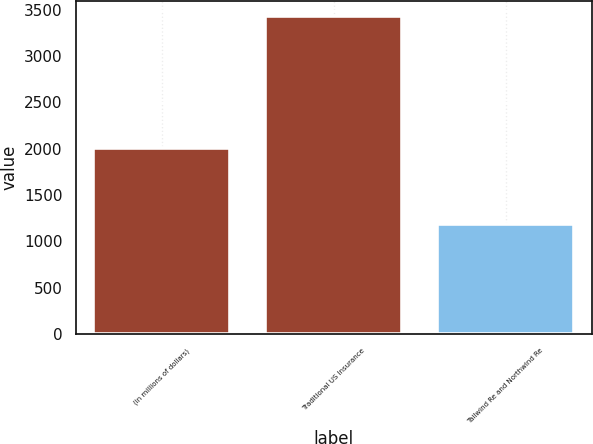<chart> <loc_0><loc_0><loc_500><loc_500><bar_chart><fcel>(in millions of dollars)<fcel>Traditional US Insurance<fcel>Tailwind Re and Northwind Re<nl><fcel>2012<fcel>3426.5<fcel>1188.4<nl></chart> 